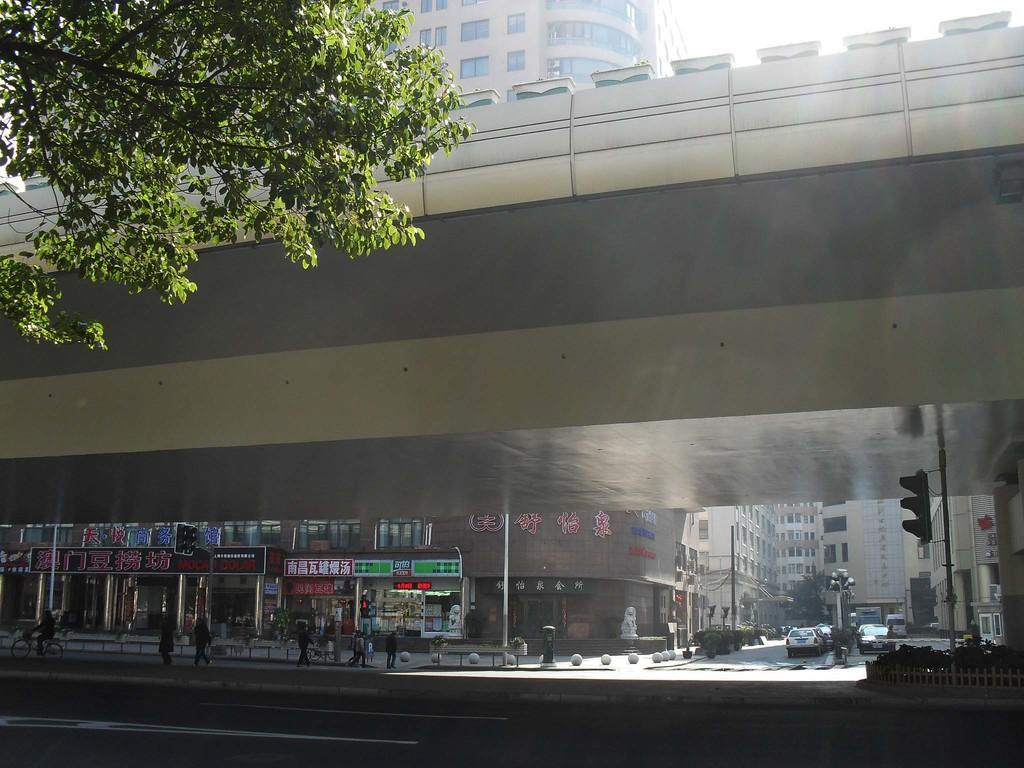Could you give a brief overview of what you see in this image? In this image there are group of people , vehicles on the road, buildings, signal lights attached to the poles, tree, plants, flyover, sky. 